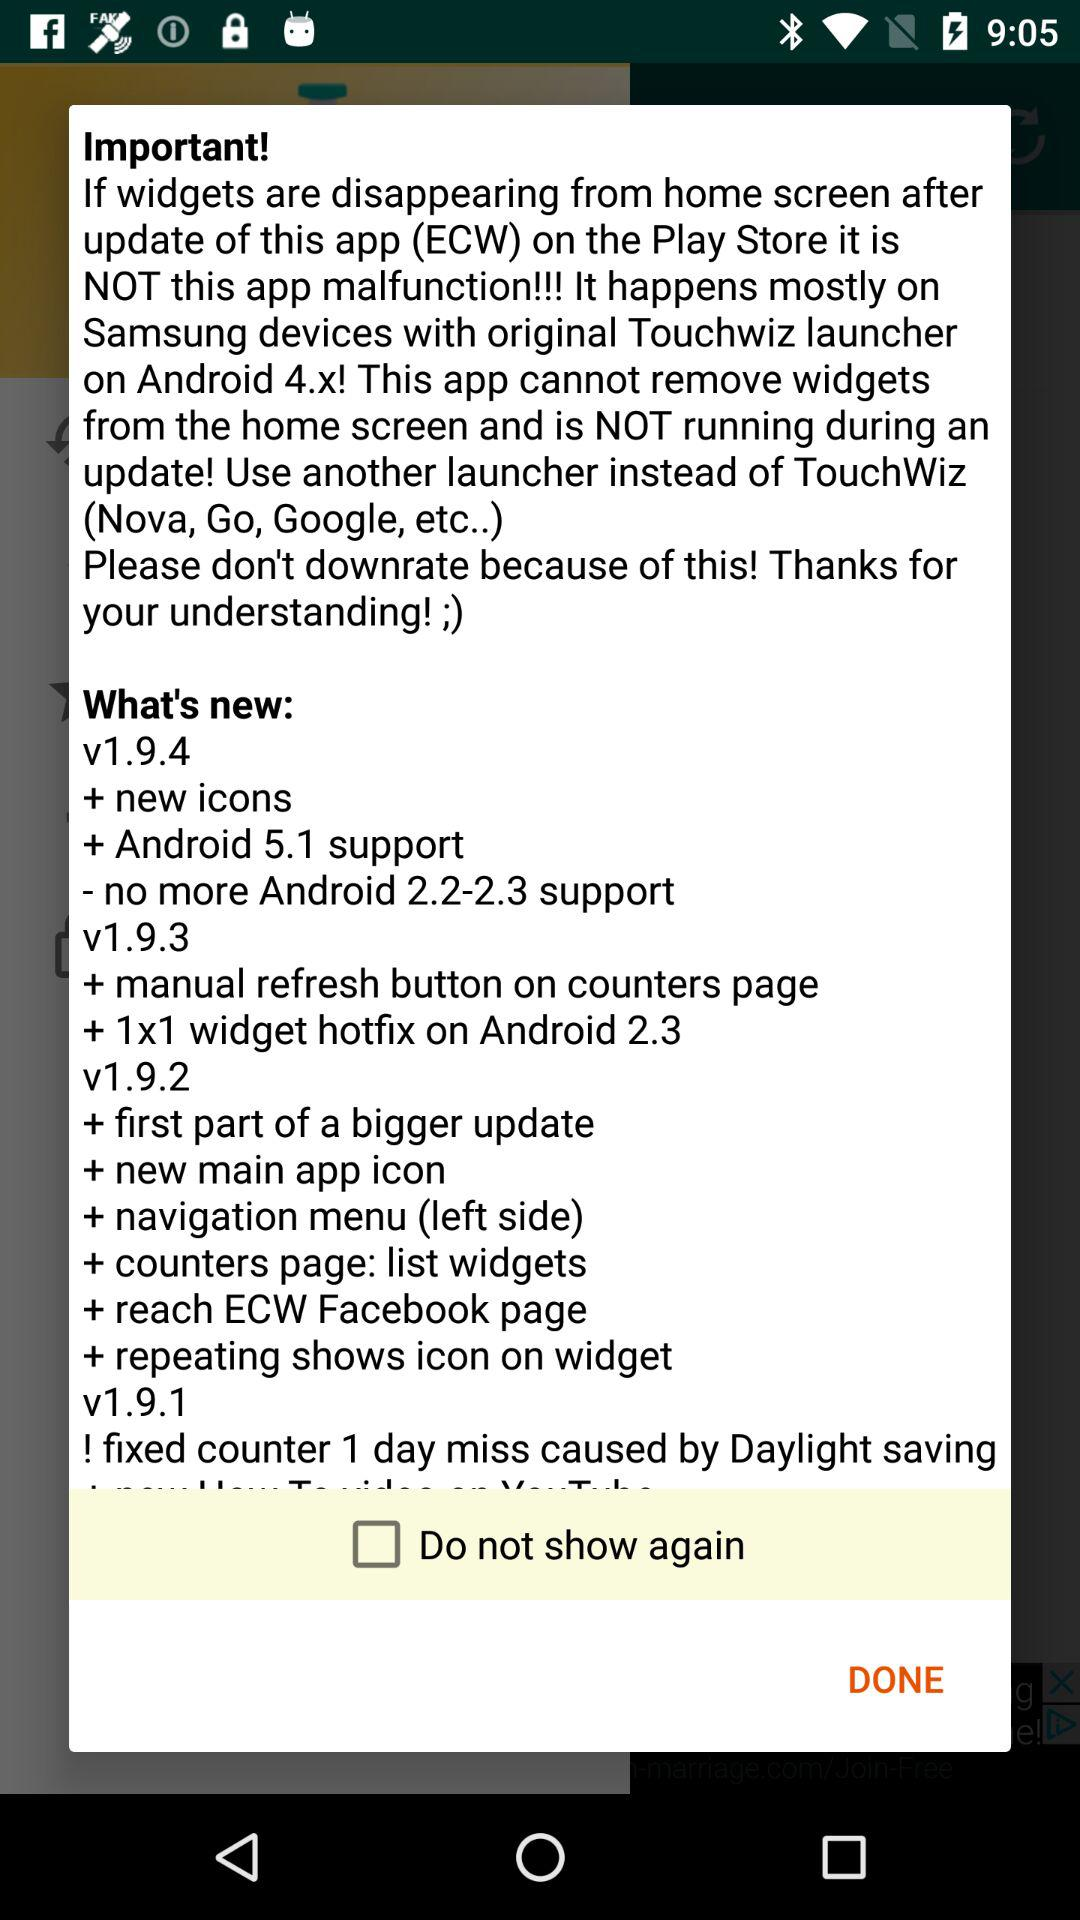What are the new updates in version 1.9.4? The new updates in version 1.9.4 are "new icons" and "Android 5.1 support". 